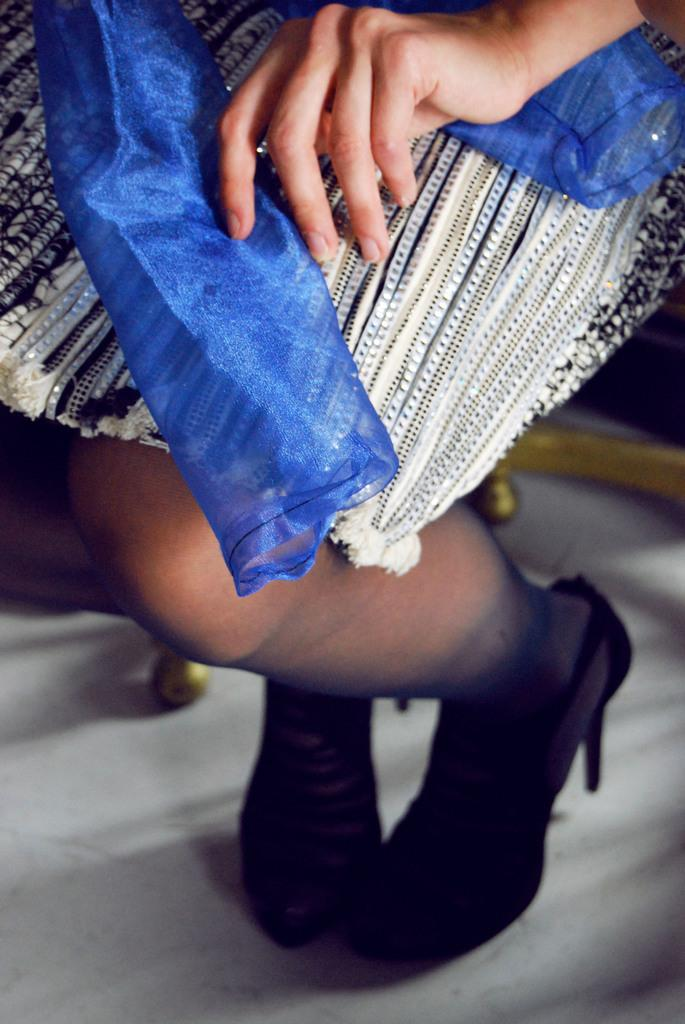What body part is visible in the image? There are person's legs visible in the image. Where are the legs located? The legs are on the floor. What type of cave can be seen in the background of the image? There is no cave present in the image; it only shows a person's legs on the floor. 